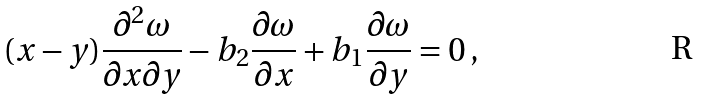<formula> <loc_0><loc_0><loc_500><loc_500>( x - y ) \frac { \partial ^ { 2 } \omega } { \partial x \partial y } - b _ { 2 } \frac { \partial \omega } { \partial x } + b _ { 1 } \frac { \partial \omega } { \partial y } = 0 \, ,</formula> 